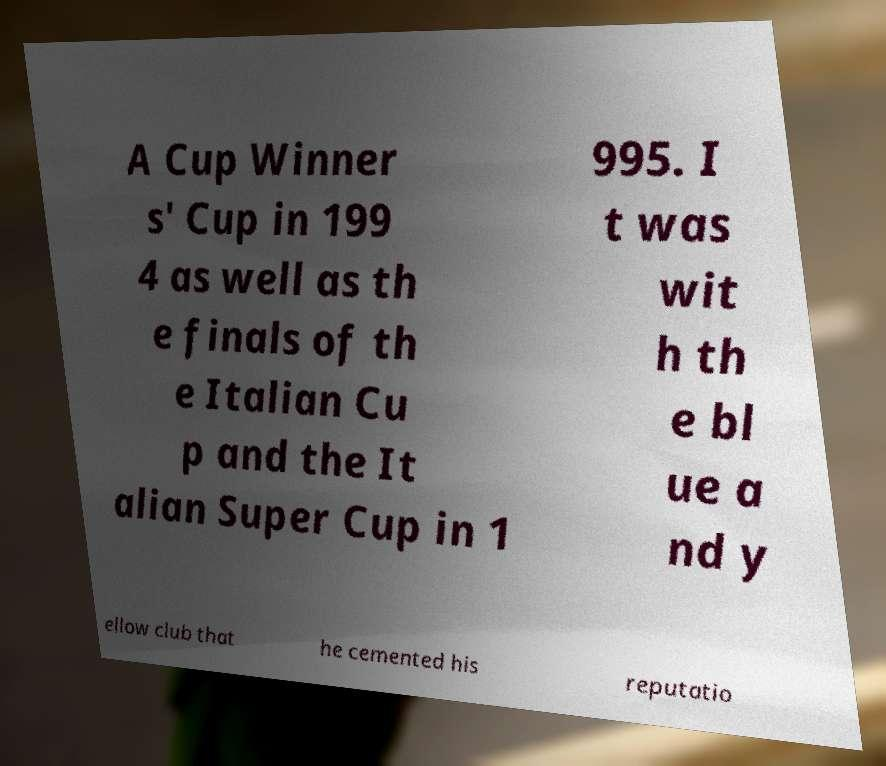There's text embedded in this image that I need extracted. Can you transcribe it verbatim? A Cup Winner s' Cup in 199 4 as well as th e finals of th e Italian Cu p and the It alian Super Cup in 1 995. I t was wit h th e bl ue a nd y ellow club that he cemented his reputatio 